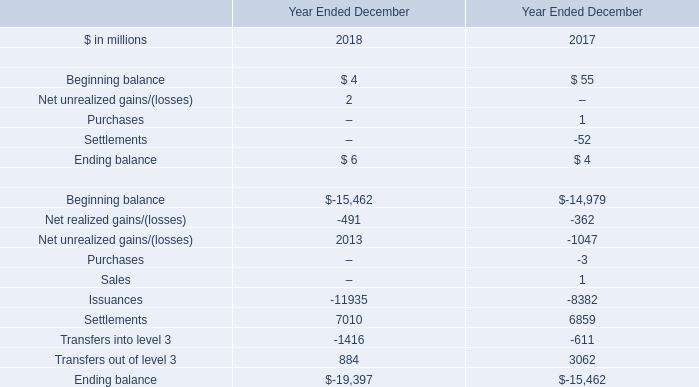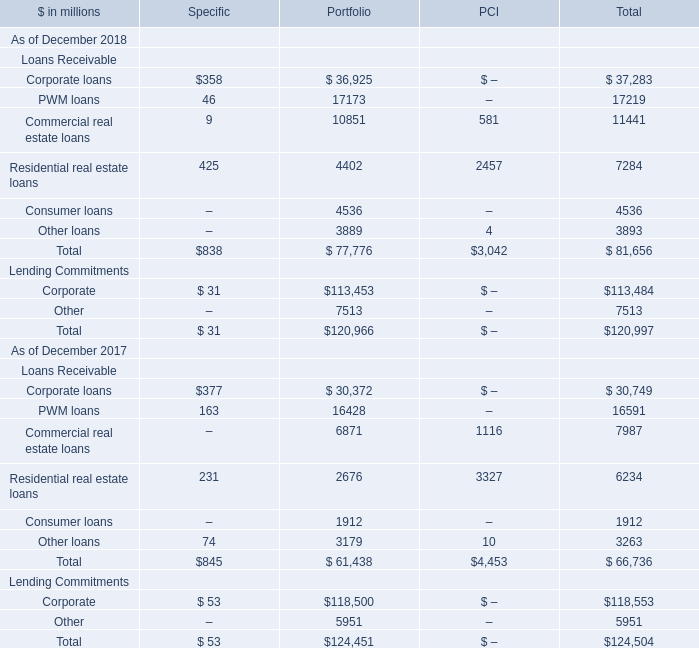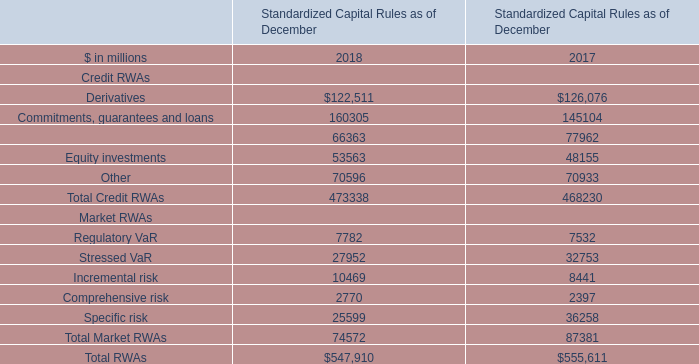What's the current increasing rate of Corporate loans for Total? 
Computations: ((37283 - 30749) / 30749)
Answer: 0.21249. 